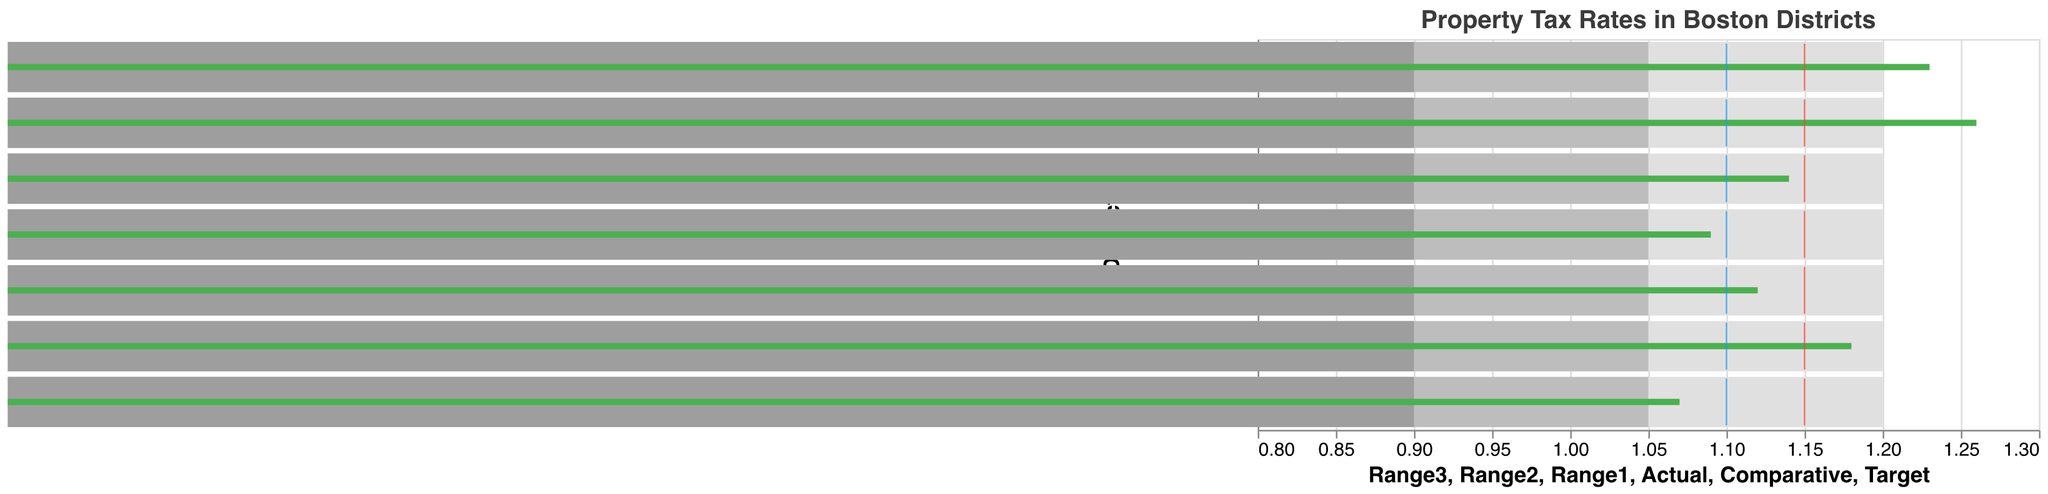What's the title of the chart? The title is clearly displayed at the top of the chart, which reads: "Property Tax Rates in Boston Districts"
Answer: Property Tax Rates in Boston Districts Which district has the highest actual property tax rate? By examining the green bars representing the actual rates, Beacon Hill shows the highest actual tax rate at 1.26
Answer: Beacon Hill What are the comparative and target rates for South Boston? The comparative rate is the red tick mark, and the target rate is the blue tick mark. For South Boston, the comparative rate is 1.15, and the target rate is 1.10
Answer: Comparative: 1.15, Target: 1.10 What is the range for actual property tax rates across all districts? By looking at the green bars, the lowest actual rate is 1.07 in West Roxbury, and the highest is 1.26 in Beacon Hill. Thus, the range is 1.26 - 1.07 = 0.19
Answer: 0.19 How does Jamaica Plain's actual property tax rate compare to its target rate? Jamaica Plain's actual rate is 1.12 (green bar) and its target rate is 1.10 (blue tick mark). The actual rate is 0.02 higher than the target rate
Answer: 0.02 higher What is the difference between the actual and comparative rates in Dorchester? Dorchester's actual rate is 1.09, and the comparative rate is 1.15. The difference is 1.15 - 1.09 = 0.06
Answer: 0.06 Which districts have an actual property tax rate higher than the comparative rate? Green bars (actual rates) higher than the red tick marks (comparative rates) are seen in Back Bay, South Boston, and Beacon Hill
Answer: Back Bay, South Boston, Beacon Hill What can you infer about the property tax rate in Charlestown given its actual, comparative, and target rates? Charlestown's actual rate is 1.14, which is just below the comparative rate of 1.15 and above the target rate of 1.10. This suggests the actual rate is closer to the comparative rate but still above the target rate, indicating it is relatively well-aligned with comparative benchmarks but slightly higher than the ideal target
Answer: Slightly higher than the target but close to the comparative How many districts have an actual property tax rate below the target rate? By comparing the green bars (actual rates) to the blue tick marks (target rates), only West Roxbury has an actual rate below the target rate (1.07 less than 1.10)
Answer: One, West Roxbury Which district is closest to achieving its target rate, and what is the difference? Jamaica Plain is closest to its target rate, with an actual rate of 1.12 and a target of 1.10, making the difference 0.02
Answer: Jamaica Plain, 0.02 